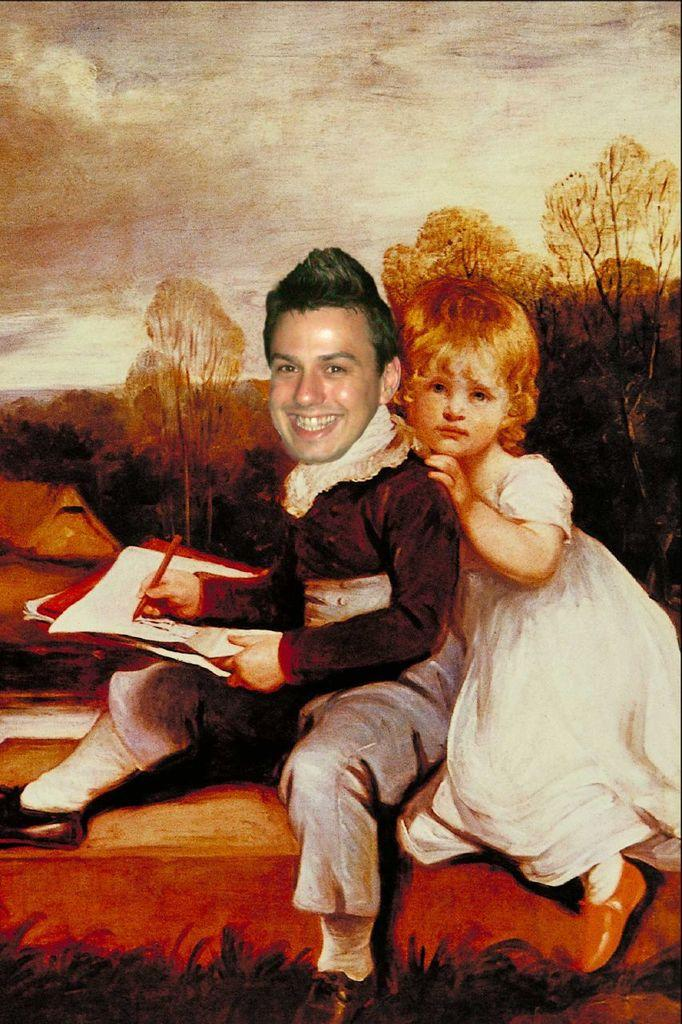What is the main subject of the painting in the image? The main subject of the painting in the image is two persons. What type of natural elements are depicted in the painting? Trees and clouds are depicted in the painting. Are there any fairies flying around the persons in the painting? There are no fairies depicted in the painting; it only features two persons, trees, and clouds. 